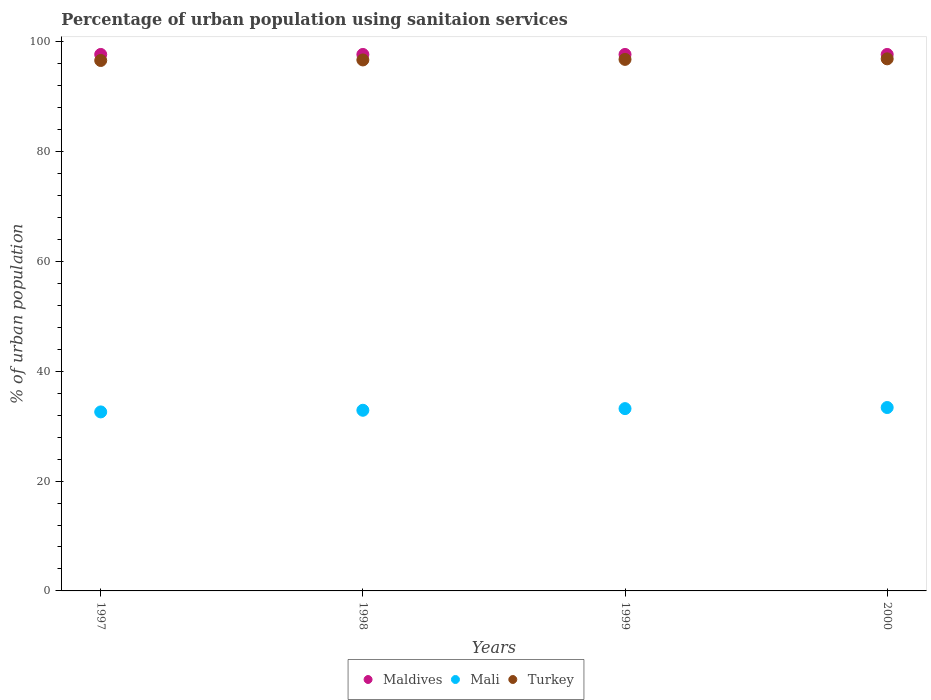Is the number of dotlines equal to the number of legend labels?
Ensure brevity in your answer.  Yes. What is the percentage of urban population using sanitaion services in Turkey in 1999?
Offer a terse response. 96.8. Across all years, what is the maximum percentage of urban population using sanitaion services in Maldives?
Offer a terse response. 97.7. Across all years, what is the minimum percentage of urban population using sanitaion services in Maldives?
Your response must be concise. 97.7. In which year was the percentage of urban population using sanitaion services in Turkey minimum?
Your response must be concise. 1997. What is the total percentage of urban population using sanitaion services in Maldives in the graph?
Your response must be concise. 390.8. What is the difference between the percentage of urban population using sanitaion services in Turkey in 1998 and the percentage of urban population using sanitaion services in Maldives in 1999?
Keep it short and to the point. -1. What is the average percentage of urban population using sanitaion services in Turkey per year?
Offer a very short reply. 96.75. In the year 1999, what is the difference between the percentage of urban population using sanitaion services in Maldives and percentage of urban population using sanitaion services in Mali?
Make the answer very short. 64.5. In how many years, is the percentage of urban population using sanitaion services in Mali greater than 60 %?
Keep it short and to the point. 0. What is the ratio of the percentage of urban population using sanitaion services in Mali in 1998 to that in 1999?
Offer a very short reply. 0.99. Is the percentage of urban population using sanitaion services in Turkey in 1999 less than that in 2000?
Your response must be concise. Yes. Is the difference between the percentage of urban population using sanitaion services in Maldives in 1999 and 2000 greater than the difference between the percentage of urban population using sanitaion services in Mali in 1999 and 2000?
Give a very brief answer. Yes. What is the difference between the highest and the second highest percentage of urban population using sanitaion services in Turkey?
Make the answer very short. 0.1. Is the sum of the percentage of urban population using sanitaion services in Turkey in 1997 and 2000 greater than the maximum percentage of urban population using sanitaion services in Mali across all years?
Provide a succinct answer. Yes. How many dotlines are there?
Give a very brief answer. 3. What is the difference between two consecutive major ticks on the Y-axis?
Offer a terse response. 20. Does the graph contain any zero values?
Your answer should be compact. No. Does the graph contain grids?
Give a very brief answer. No. Where does the legend appear in the graph?
Your response must be concise. Bottom center. How many legend labels are there?
Provide a short and direct response. 3. What is the title of the graph?
Give a very brief answer. Percentage of urban population using sanitaion services. What is the label or title of the Y-axis?
Provide a short and direct response. % of urban population. What is the % of urban population in Maldives in 1997?
Your answer should be compact. 97.7. What is the % of urban population in Mali in 1997?
Provide a succinct answer. 32.6. What is the % of urban population in Turkey in 1997?
Your response must be concise. 96.6. What is the % of urban population in Maldives in 1998?
Keep it short and to the point. 97.7. What is the % of urban population in Mali in 1998?
Your answer should be very brief. 32.9. What is the % of urban population in Turkey in 1998?
Keep it short and to the point. 96.7. What is the % of urban population in Maldives in 1999?
Provide a short and direct response. 97.7. What is the % of urban population in Mali in 1999?
Provide a short and direct response. 33.2. What is the % of urban population of Turkey in 1999?
Offer a very short reply. 96.8. What is the % of urban population of Maldives in 2000?
Offer a terse response. 97.7. What is the % of urban population of Mali in 2000?
Provide a short and direct response. 33.4. What is the % of urban population in Turkey in 2000?
Your response must be concise. 96.9. Across all years, what is the maximum % of urban population of Maldives?
Provide a short and direct response. 97.7. Across all years, what is the maximum % of urban population in Mali?
Your answer should be compact. 33.4. Across all years, what is the maximum % of urban population of Turkey?
Your answer should be very brief. 96.9. Across all years, what is the minimum % of urban population of Maldives?
Offer a terse response. 97.7. Across all years, what is the minimum % of urban population in Mali?
Provide a short and direct response. 32.6. Across all years, what is the minimum % of urban population in Turkey?
Offer a very short reply. 96.6. What is the total % of urban population of Maldives in the graph?
Your response must be concise. 390.8. What is the total % of urban population of Mali in the graph?
Your response must be concise. 132.1. What is the total % of urban population in Turkey in the graph?
Your answer should be very brief. 387. What is the difference between the % of urban population in Maldives in 1997 and that in 1998?
Provide a short and direct response. 0. What is the difference between the % of urban population in Turkey in 1997 and that in 1999?
Your answer should be very brief. -0.2. What is the difference between the % of urban population in Maldives in 1997 and that in 2000?
Provide a succinct answer. 0. What is the difference between the % of urban population of Maldives in 1998 and that in 1999?
Your answer should be compact. 0. What is the difference between the % of urban population of Turkey in 1998 and that in 2000?
Provide a succinct answer. -0.2. What is the difference between the % of urban population of Turkey in 1999 and that in 2000?
Give a very brief answer. -0.1. What is the difference between the % of urban population of Maldives in 1997 and the % of urban population of Mali in 1998?
Provide a succinct answer. 64.8. What is the difference between the % of urban population of Mali in 1997 and the % of urban population of Turkey in 1998?
Provide a succinct answer. -64.1. What is the difference between the % of urban population in Maldives in 1997 and the % of urban population in Mali in 1999?
Offer a very short reply. 64.5. What is the difference between the % of urban population of Maldives in 1997 and the % of urban population of Turkey in 1999?
Your answer should be very brief. 0.9. What is the difference between the % of urban population of Mali in 1997 and the % of urban population of Turkey in 1999?
Offer a very short reply. -64.2. What is the difference between the % of urban population of Maldives in 1997 and the % of urban population of Mali in 2000?
Your response must be concise. 64.3. What is the difference between the % of urban population of Mali in 1997 and the % of urban population of Turkey in 2000?
Your answer should be very brief. -64.3. What is the difference between the % of urban population of Maldives in 1998 and the % of urban population of Mali in 1999?
Your response must be concise. 64.5. What is the difference between the % of urban population in Maldives in 1998 and the % of urban population in Turkey in 1999?
Offer a terse response. 0.9. What is the difference between the % of urban population in Mali in 1998 and the % of urban population in Turkey in 1999?
Keep it short and to the point. -63.9. What is the difference between the % of urban population of Maldives in 1998 and the % of urban population of Mali in 2000?
Make the answer very short. 64.3. What is the difference between the % of urban population of Mali in 1998 and the % of urban population of Turkey in 2000?
Offer a terse response. -64. What is the difference between the % of urban population of Maldives in 1999 and the % of urban population of Mali in 2000?
Give a very brief answer. 64.3. What is the difference between the % of urban population of Maldives in 1999 and the % of urban population of Turkey in 2000?
Offer a very short reply. 0.8. What is the difference between the % of urban population of Mali in 1999 and the % of urban population of Turkey in 2000?
Your response must be concise. -63.7. What is the average % of urban population in Maldives per year?
Provide a short and direct response. 97.7. What is the average % of urban population of Mali per year?
Offer a very short reply. 33.02. What is the average % of urban population of Turkey per year?
Ensure brevity in your answer.  96.75. In the year 1997, what is the difference between the % of urban population in Maldives and % of urban population in Mali?
Keep it short and to the point. 65.1. In the year 1997, what is the difference between the % of urban population in Maldives and % of urban population in Turkey?
Offer a terse response. 1.1. In the year 1997, what is the difference between the % of urban population of Mali and % of urban population of Turkey?
Give a very brief answer. -64. In the year 1998, what is the difference between the % of urban population in Maldives and % of urban population in Mali?
Your answer should be compact. 64.8. In the year 1998, what is the difference between the % of urban population in Mali and % of urban population in Turkey?
Provide a succinct answer. -63.8. In the year 1999, what is the difference between the % of urban population of Maldives and % of urban population of Mali?
Make the answer very short. 64.5. In the year 1999, what is the difference between the % of urban population of Maldives and % of urban population of Turkey?
Your answer should be very brief. 0.9. In the year 1999, what is the difference between the % of urban population of Mali and % of urban population of Turkey?
Your response must be concise. -63.6. In the year 2000, what is the difference between the % of urban population of Maldives and % of urban population of Mali?
Make the answer very short. 64.3. In the year 2000, what is the difference between the % of urban population in Mali and % of urban population in Turkey?
Your answer should be very brief. -63.5. What is the ratio of the % of urban population of Mali in 1997 to that in 1998?
Give a very brief answer. 0.99. What is the ratio of the % of urban population of Maldives in 1997 to that in 1999?
Ensure brevity in your answer.  1. What is the ratio of the % of urban population in Mali in 1997 to that in 1999?
Provide a succinct answer. 0.98. What is the ratio of the % of urban population of Turkey in 1997 to that in 1999?
Offer a very short reply. 1. What is the ratio of the % of urban population in Maldives in 1998 to that in 1999?
Offer a terse response. 1. What is the ratio of the % of urban population of Turkey in 1998 to that in 1999?
Ensure brevity in your answer.  1. What is the ratio of the % of urban population of Maldives in 1999 to that in 2000?
Ensure brevity in your answer.  1. What is the difference between the highest and the second highest % of urban population of Maldives?
Your response must be concise. 0. What is the difference between the highest and the second highest % of urban population of Turkey?
Ensure brevity in your answer.  0.1. What is the difference between the highest and the lowest % of urban population in Turkey?
Your answer should be very brief. 0.3. 